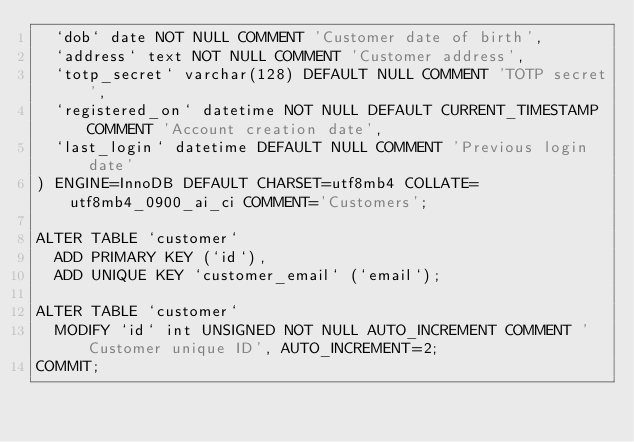<code> <loc_0><loc_0><loc_500><loc_500><_SQL_>  `dob` date NOT NULL COMMENT 'Customer date of birth',
  `address` text NOT NULL COMMENT 'Customer address',
  `totp_secret` varchar(128) DEFAULT NULL COMMENT 'TOTP secret',
  `registered_on` datetime NOT NULL DEFAULT CURRENT_TIMESTAMP COMMENT 'Account creation date',
  `last_login` datetime DEFAULT NULL COMMENT 'Previous login date'
) ENGINE=InnoDB DEFAULT CHARSET=utf8mb4 COLLATE=utf8mb4_0900_ai_ci COMMENT='Customers';

ALTER TABLE `customer`
  ADD PRIMARY KEY (`id`),
  ADD UNIQUE KEY `customer_email` (`email`);

ALTER TABLE `customer`
  MODIFY `id` int UNSIGNED NOT NULL AUTO_INCREMENT COMMENT 'Customer unique ID', AUTO_INCREMENT=2;
COMMIT;</code> 